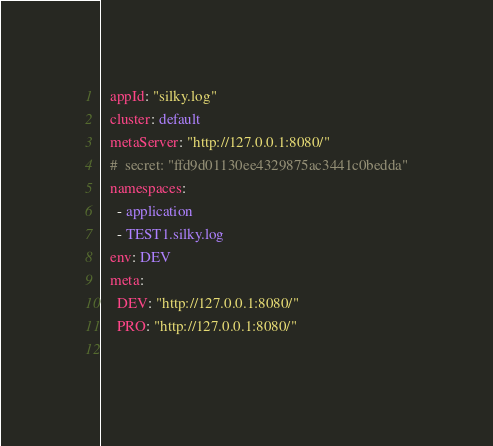Convert code to text. <code><loc_0><loc_0><loc_500><loc_500><_YAML_>  appId: "silky.log"
  cluster: default
  metaServer: "http://127.0.0.1:8080/"
  #  secret: "ffd9d01130ee4329875ac3441c0bedda"
  namespaces:
    - application
    - TEST1.silky.log
  env: DEV
  meta:
    DEV: "http://127.0.0.1:8080/"
    PRO: "http://127.0.0.1:8080/"
    </code> 